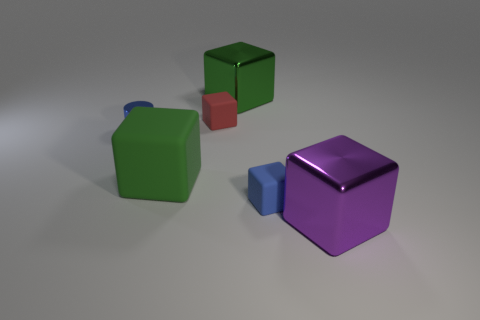Is the number of blue matte objects to the right of the blue metal cylinder less than the number of red objects that are on the right side of the purple metal thing?
Provide a short and direct response. No. What number of yellow cylinders are there?
Offer a terse response. 0. Is there anything else that is made of the same material as the cylinder?
Keep it short and to the point. Yes. There is a small blue thing that is the same shape as the big green shiny thing; what material is it?
Offer a terse response. Rubber. Are there fewer small blue blocks behind the purple metal object than matte cubes?
Your answer should be very brief. Yes. Does the small blue metal thing in front of the small red cube have the same shape as the big purple thing?
Offer a very short reply. No. Is there anything else that is the same color as the small shiny cylinder?
Make the answer very short. Yes. What is the size of the green object that is the same material as the purple thing?
Provide a short and direct response. Large. What material is the tiny blue thing to the left of the large shiny block behind the large shiny object that is in front of the small blue cylinder made of?
Make the answer very short. Metal. Is the number of big yellow shiny balls less than the number of purple shiny cubes?
Offer a terse response. Yes. 